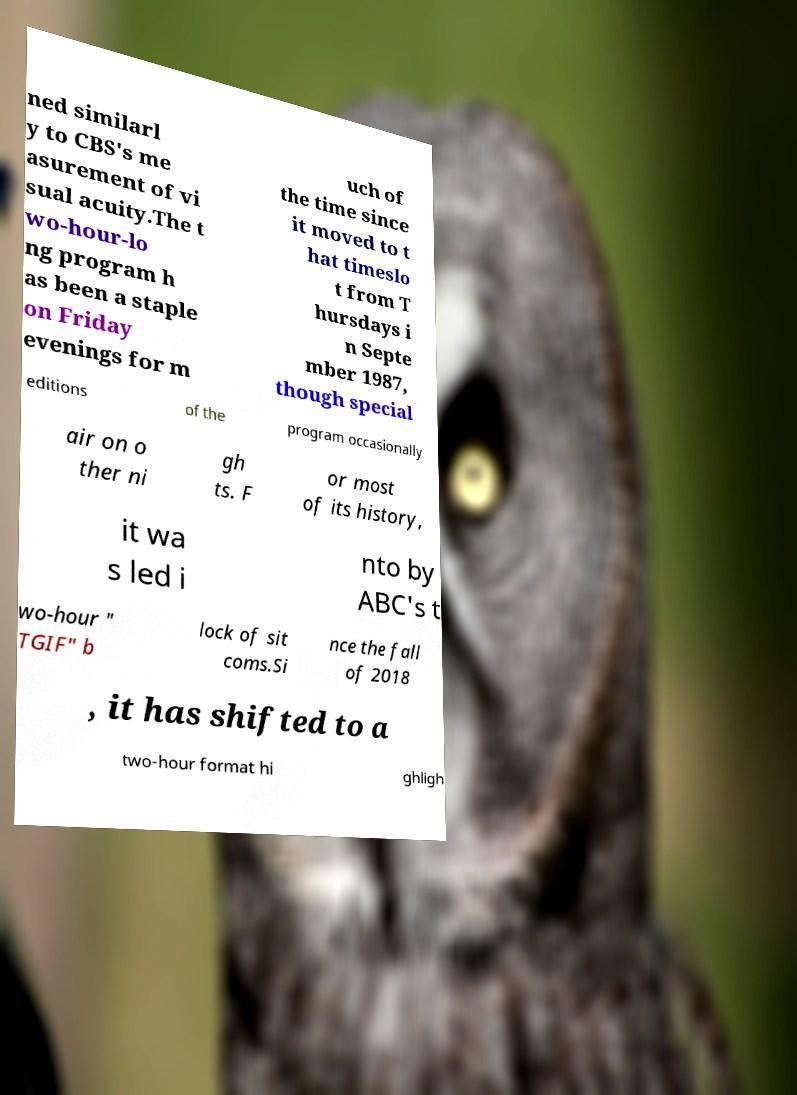Can you read and provide the text displayed in the image?This photo seems to have some interesting text. Can you extract and type it out for me? ned similarl y to CBS's me asurement of vi sual acuity.The t wo-hour-lo ng program h as been a staple on Friday evenings for m uch of the time since it moved to t hat timeslo t from T hursdays i n Septe mber 1987, though special editions of the program occasionally air on o ther ni gh ts. F or most of its history, it wa s led i nto by ABC's t wo-hour " TGIF" b lock of sit coms.Si nce the fall of 2018 , it has shifted to a two-hour format hi ghligh 